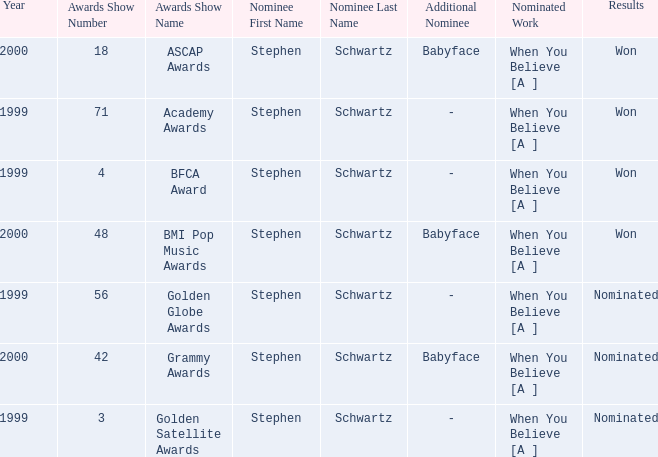What was the result in 2000? Won, Won, Nominated. 